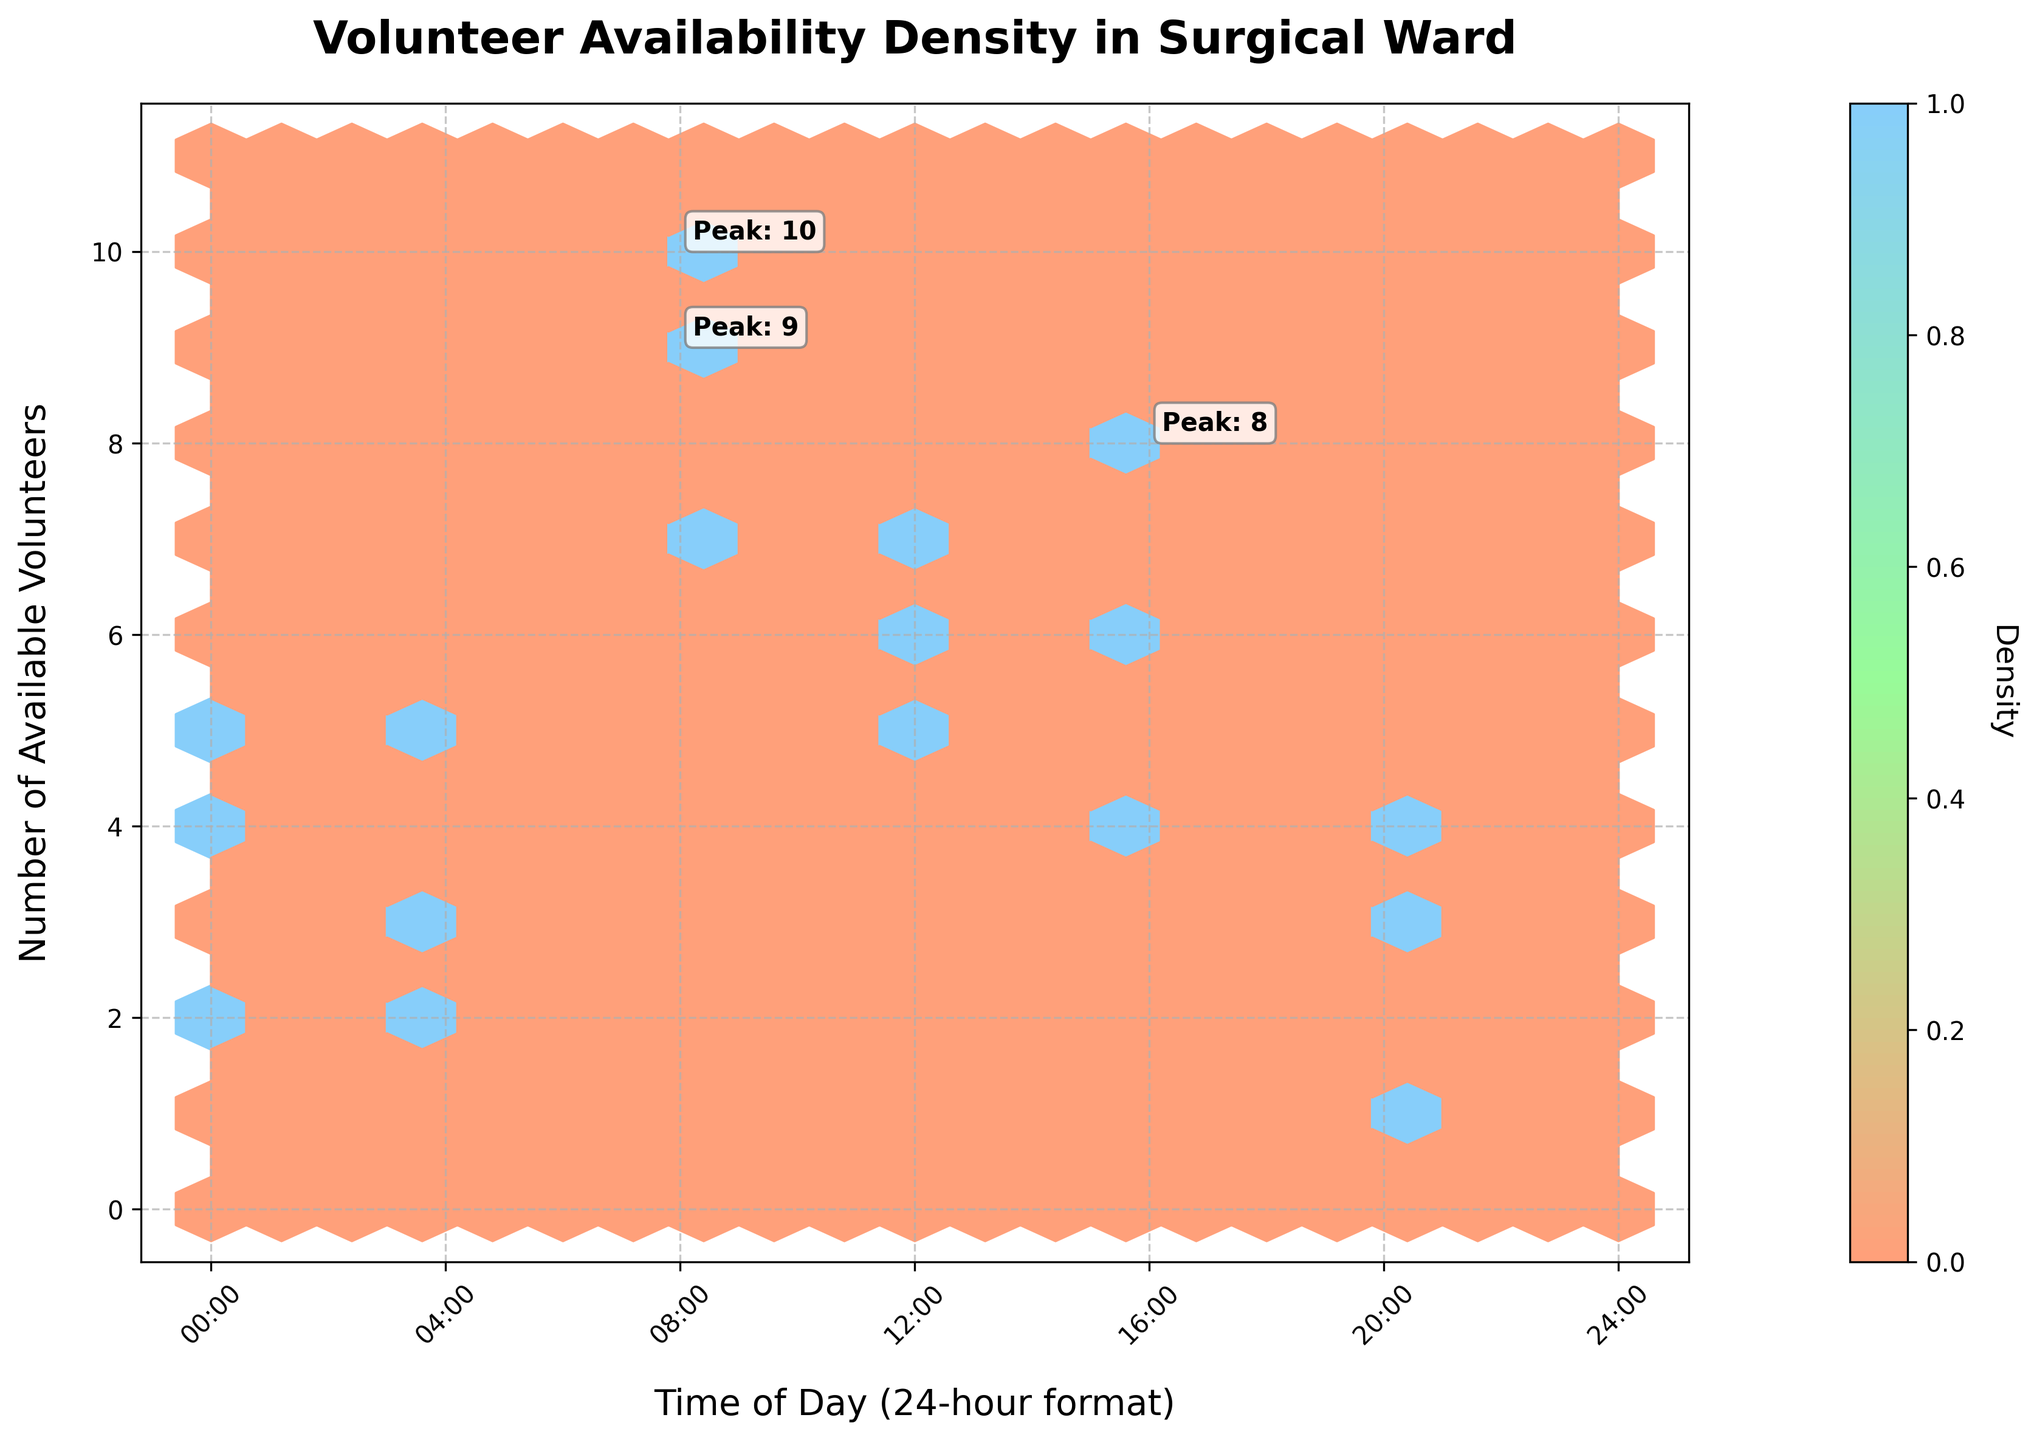What is the title of the plot? The title is always the most prominent text at the top of the figure. Look for the largest, bold text centered at the top.
Answer: Volunteer Availability Density in Surgical Ward What is the x-axis label? The label for the x-axis is located directly below the horizontal axis, indicating what the axis represents.
Answer: Time of Day (24-hour format) What is the highest number of available volunteers at any given time? To find the highest number, observe the maximum value on the y-axis or look for the highest density points in the plot.
Answer: 10 Which time period shows the highest density of volunteer availability? Density is represented by the color intensity in a hexbin plot. The time period with the most intense coloration in the plot corresponds to the highest density.
Answer: 08:00-12:00 How does volunteer availability between 16:00-20:00 compare to that between 20:00-00:00? Compare the density and the y-axis values for both time periods. Observe the corresponding shades and the count on the y-axis.
Answer: 16:00-20:00 has higher availability What are the peak times with the highest number of volunteers annotated in the plot? Look for annotations directly on the plot. These should be indicated with small text labels or notes pointing to the peaks.
Answer: 08:00-12:00, 08:00-12:00, 16:00-20:00 How many peak times are annotated in the plot? Count the number of annotations identifying peak volunteer availabilities on the plot.
Answer: 3 If we sum the volunteer availability at 12:00-16:00 and 16:00-20:00, what is the total? Identify the availability number for each time period and add them together.
Answer: 7 + 6 = 13 Compare volunteer availability at 00:00-04:00 in the plot's different data points. What trend can you observe? Look at the density and availability values shown at 00:00-04:00 across multiple data points and identify if the values are increasing, decreasing, or fluctuating.
Answer: Fluctuating What color scale is used in the plot to indicate density? Observe the gradient legend next to the plot, which indicates the range of colors used to represent various densities.
Answer: A gradient from light orange to light blue 